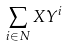<formula> <loc_0><loc_0><loc_500><loc_500>\sum _ { i \in N } X Y ^ { i }</formula> 